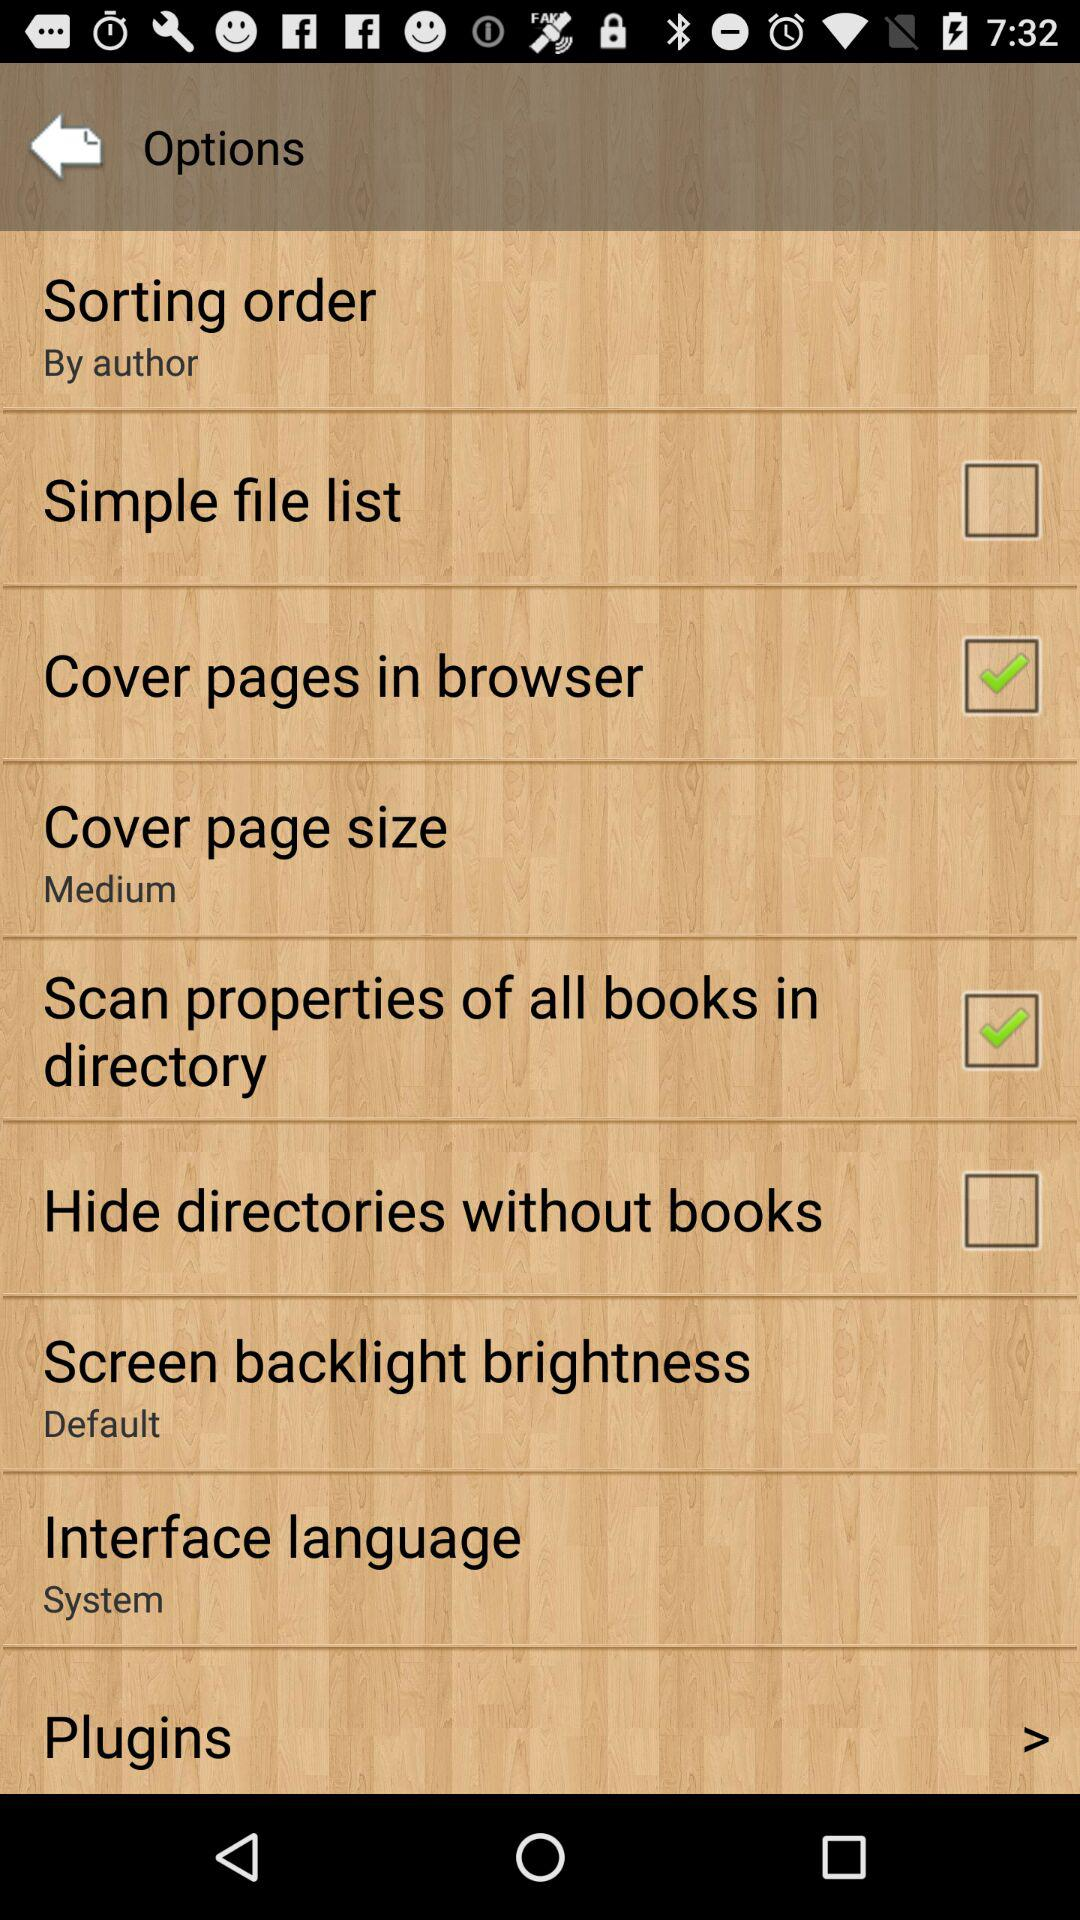What is the selected "Screen backlight brightness"? The selected "Screen backlight brightness" is "Default". 